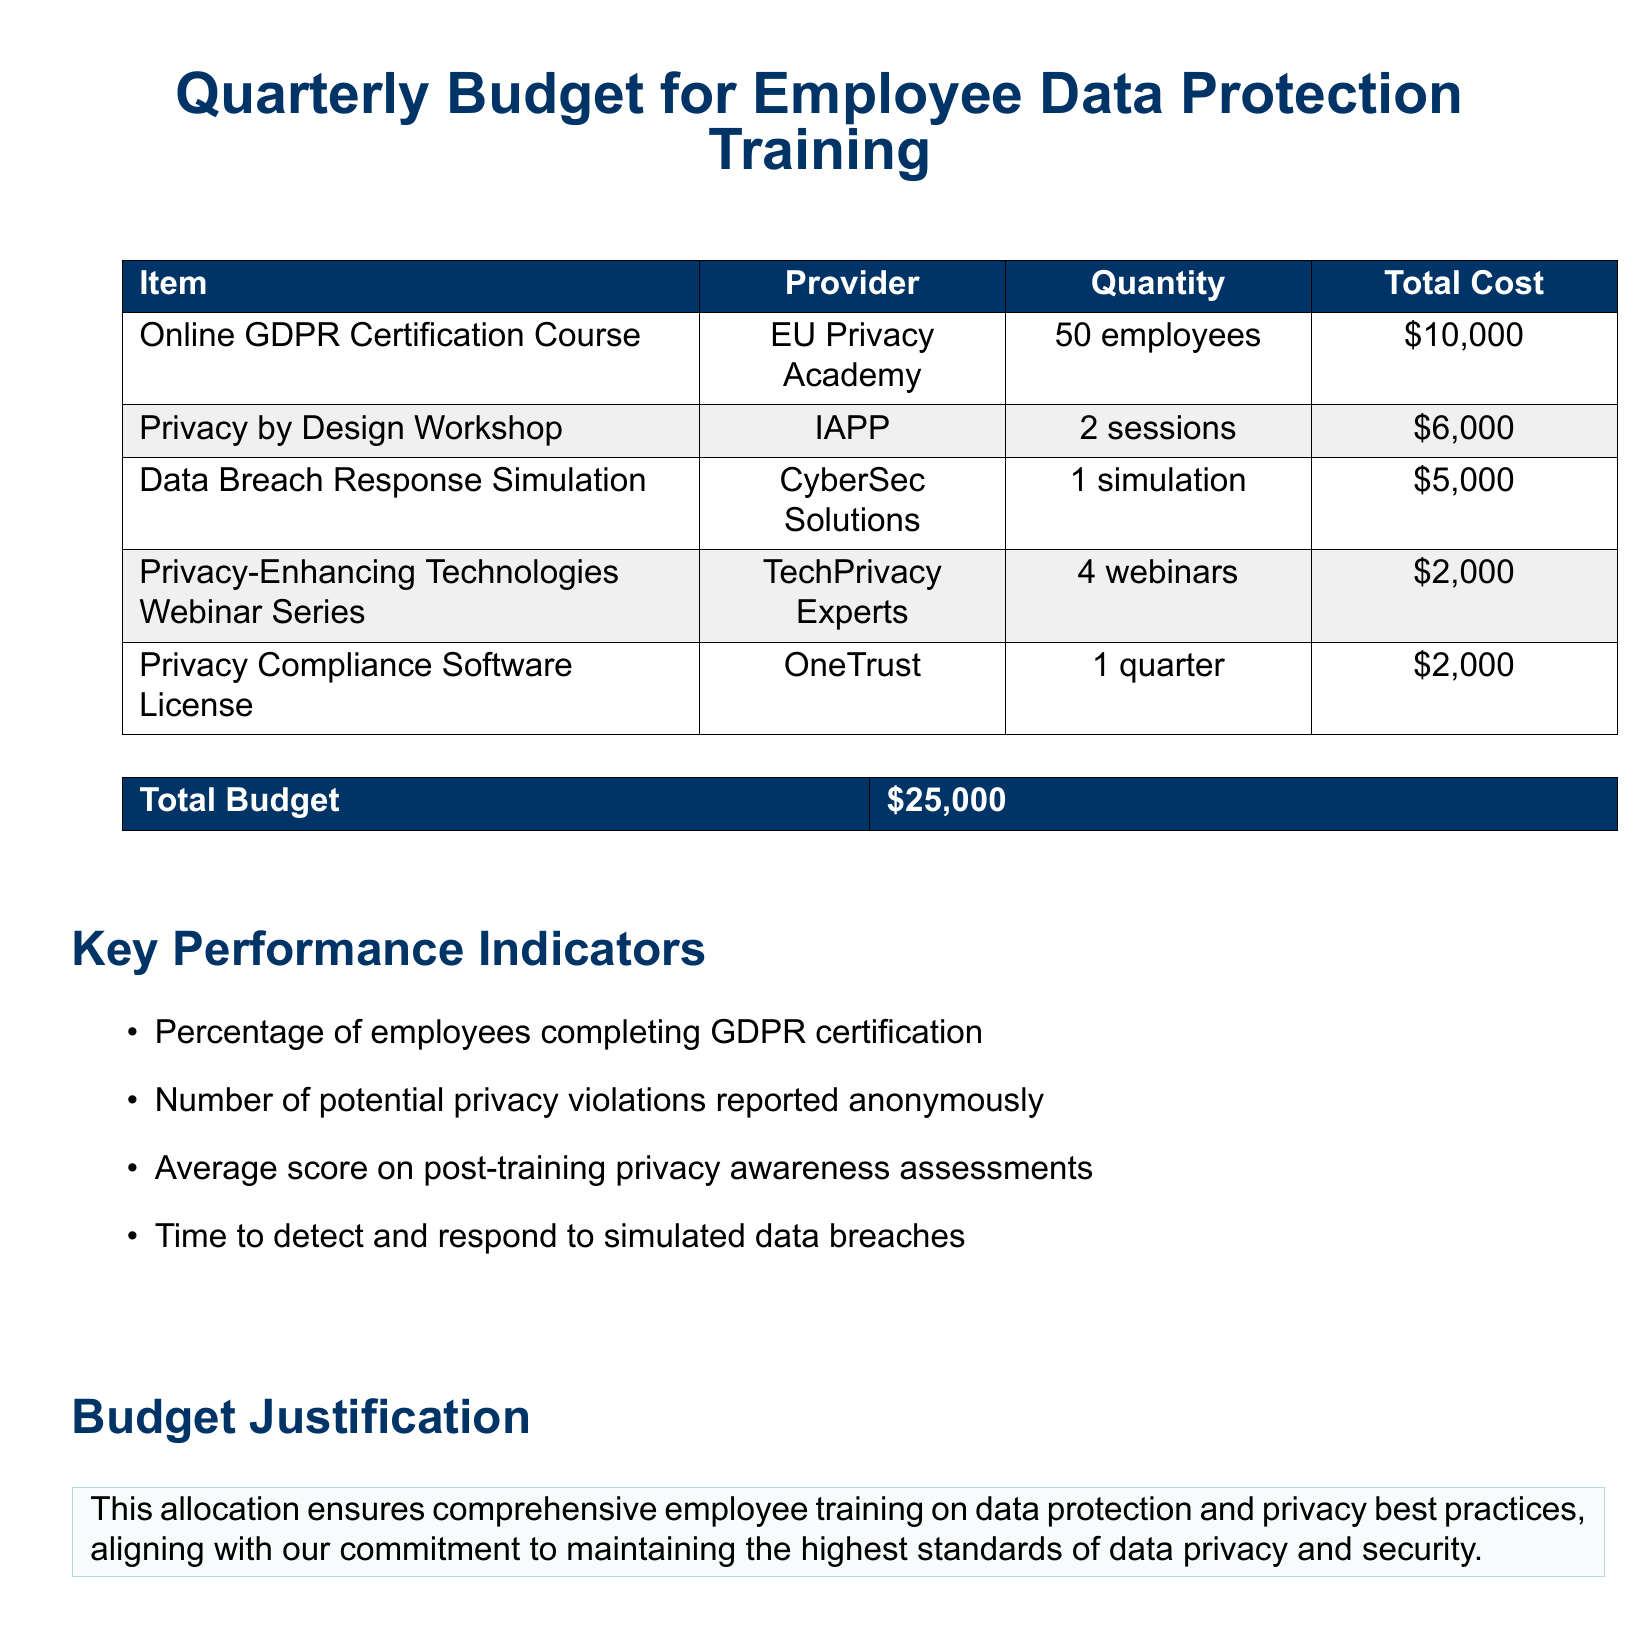What is the total budget? The total budget is explicitly stated in the document as the overall amount allocated for employee training on data protection and privacy best practices.
Answer: $25,000 Who is the provider for the Online GDPR Certification Course? The provider for the Online GDPR Certification Course is mentioned in the document as the organization delivering this training.
Answer: EU Privacy Academy How many employees are eligible for the Privacy by Design Workshop? The document specifies the number of sessions and eligible employees for this training, hence requiring a count of the sessions and information about the employees.
Answer: 2 sessions What is the cost of the Data Breach Response Simulation? The document lists the cost associated with this training item, which can be retrieved directly from the total cost column.
Answer: $5,000 What key performance indicator reflects the effectiveness of the training? The document includes various indicators, and one can be identified as measuring the successful outcome of the training on employees.
Answer: Percentage of employees completing GDPR certification How many webinars are included in the Privacy-Enhancing Technologies Webinar Series? The document outlines the number of webinars provided as part of this training, hence this is a straightforward retrieval of that value.
Answer: 4 webinars What is the purpose of the budget justification section? The budget justification clarifies the rationale for the financial allocation presented in the document, hence explaining why such amounts were set aside.
Answer: Comprehensive training alignment What is the quantity of the Privacy Compliance Software License? The document states the corresponding service for one quarter, requiring the retrieval of this specific quantity noted in the budget.
Answer: 1 quarter What is the total cost for the Privacy by Design Workshop? The document specifies this item's financial allocation clearly, allowing for direct extraction of its associated total cost.
Answer: $6,000 